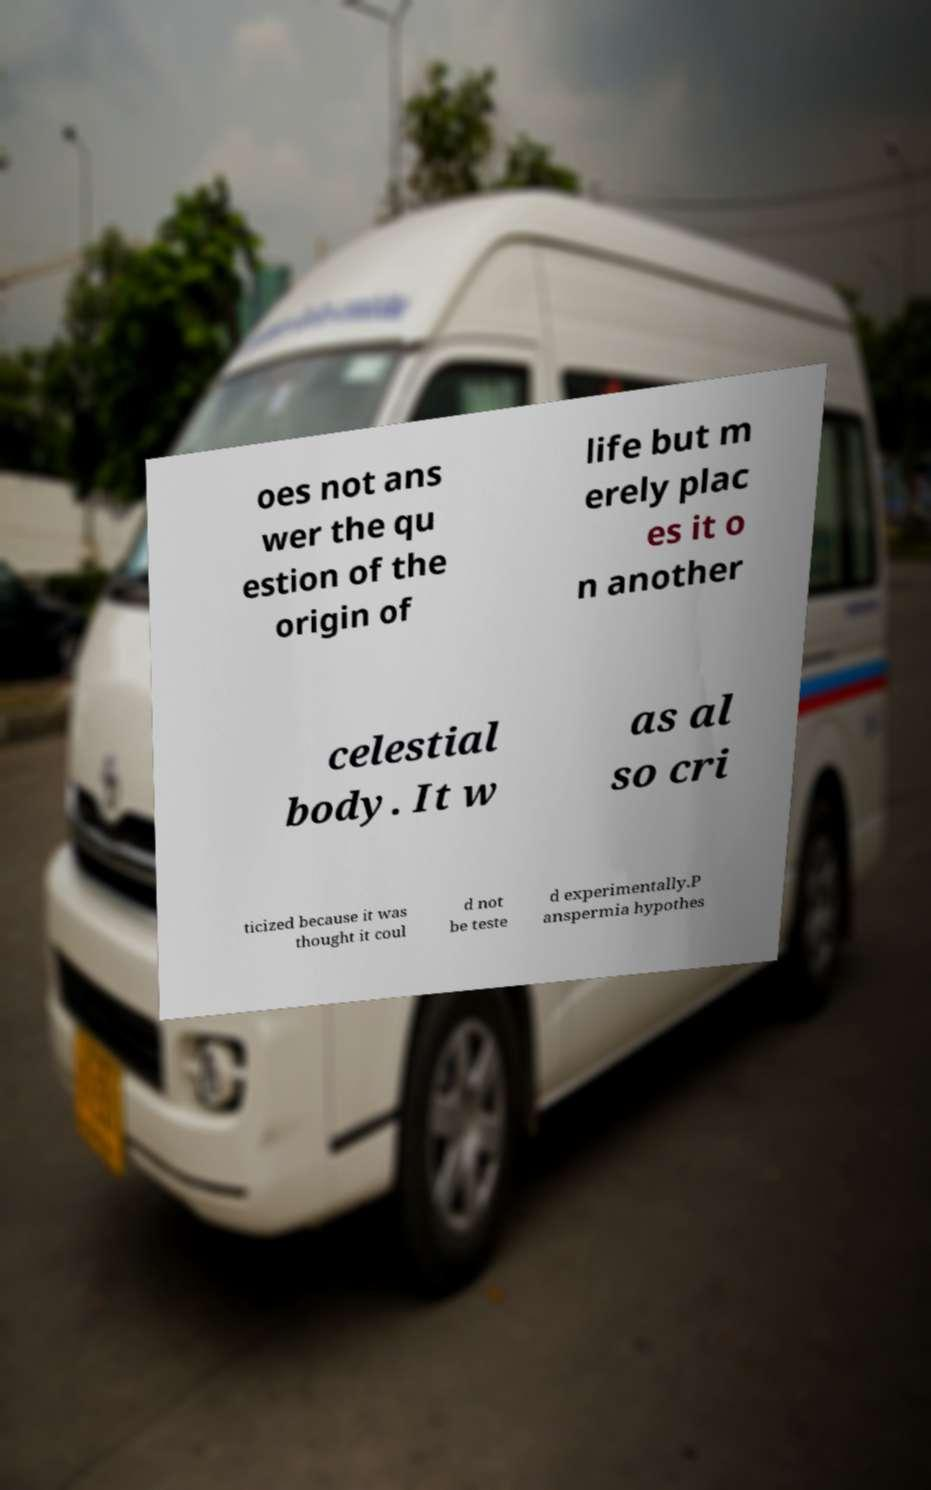Please read and relay the text visible in this image. What does it say? oes not ans wer the qu estion of the origin of life but m erely plac es it o n another celestial body. It w as al so cri ticized because it was thought it coul d not be teste d experimentally.P anspermia hypothes 